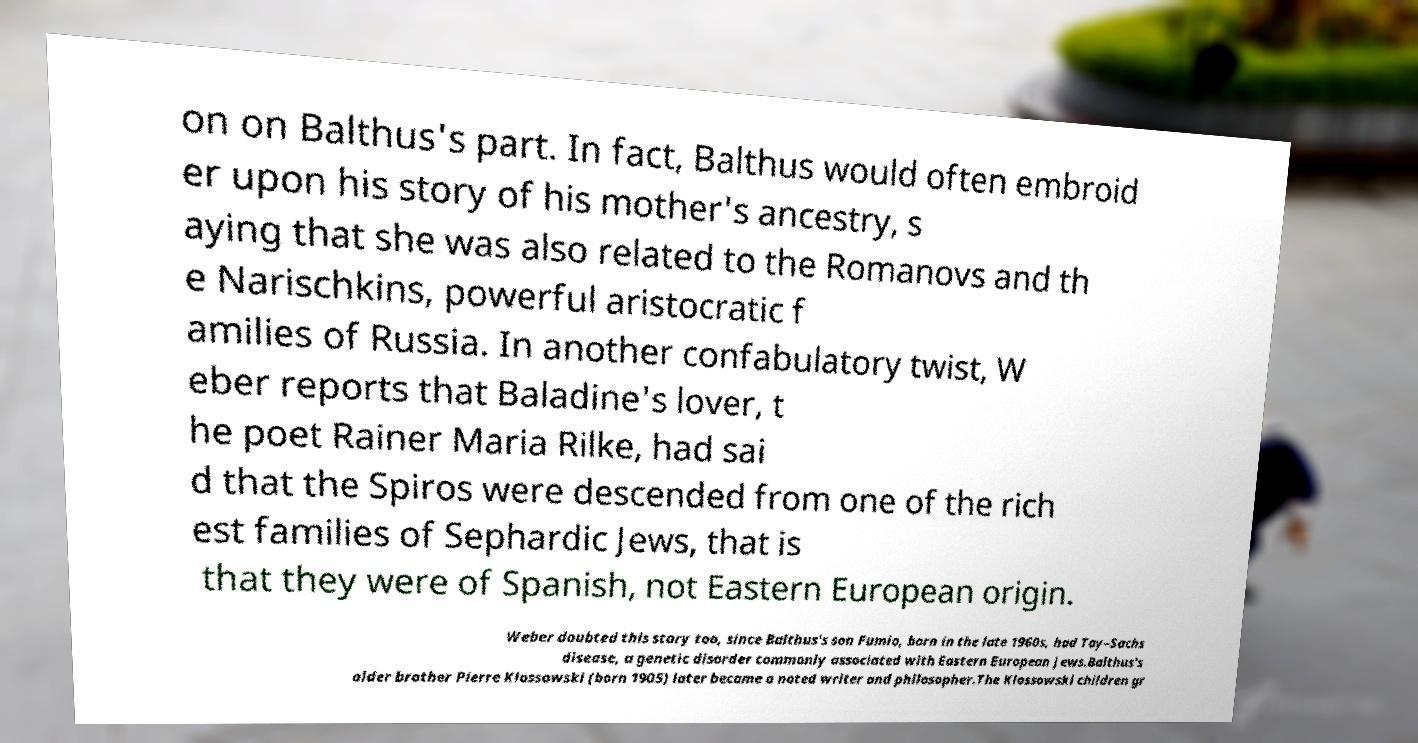What messages or text are displayed in this image? I need them in a readable, typed format. on on Balthus's part. In fact, Balthus would often embroid er upon his story of his mother's ancestry, s aying that she was also related to the Romanovs and th e Narischkins, powerful aristocratic f amilies of Russia. In another confabulatory twist, W eber reports that Baladine's lover, t he poet Rainer Maria Rilke, had sai d that the Spiros were descended from one of the rich est families of Sephardic Jews, that is that they were of Spanish, not Eastern European origin. Weber doubted this story too, since Balthus's son Fumio, born in the late 1960s, had Tay–Sachs disease, a genetic disorder commonly associated with Eastern European Jews.Balthus's older brother Pierre Klossowski (born 1905) later became a noted writer and philosopher.The Klossowski children gr 